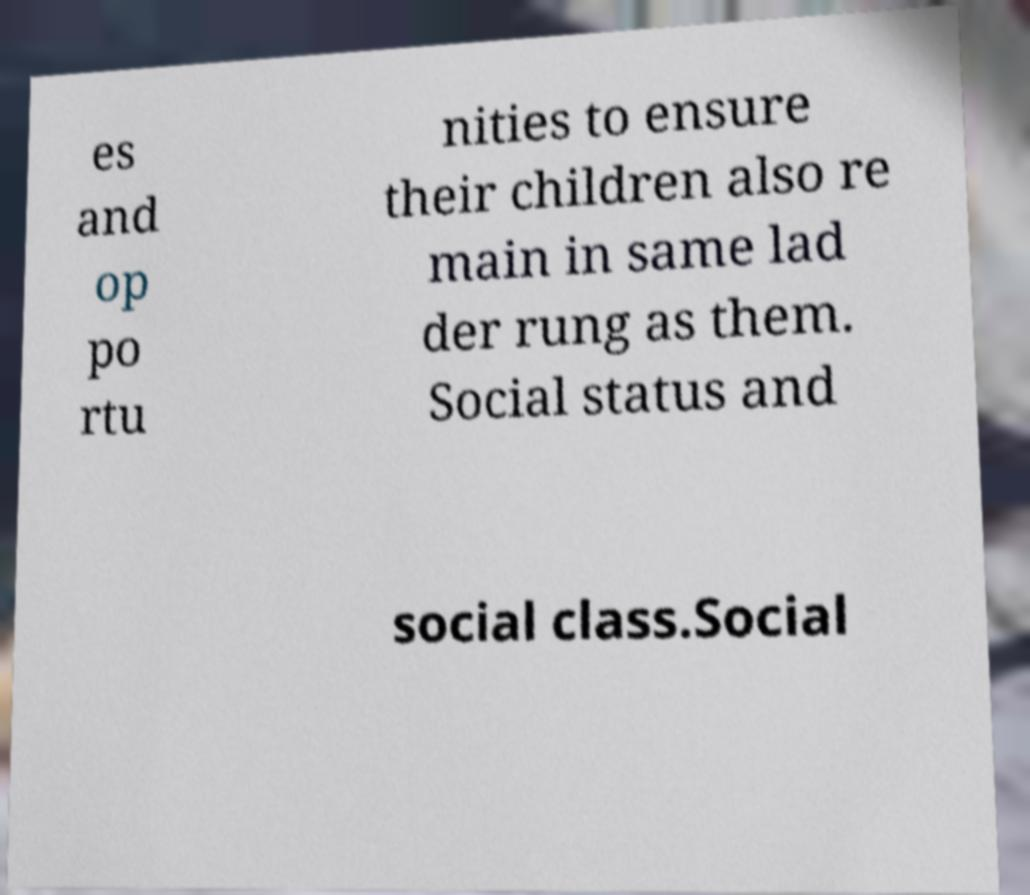Could you extract and type out the text from this image? es and op po rtu nities to ensure their children also re main in same lad der rung as them. Social status and social class.Social 